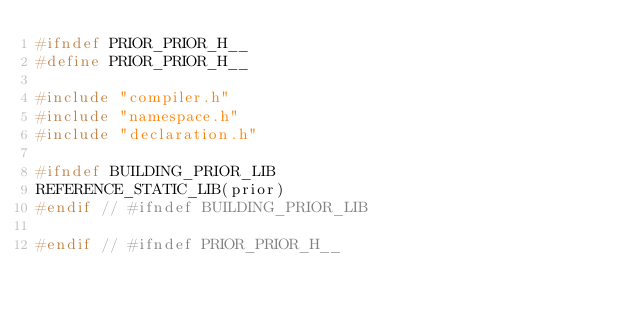Convert code to text. <code><loc_0><loc_0><loc_500><loc_500><_C_>#ifndef PRIOR_PRIOR_H__
#define PRIOR_PRIOR_H__

#include "compiler.h"
#include "namespace.h"
#include "declaration.h"

#ifndef BUILDING_PRIOR_LIB
REFERENCE_STATIC_LIB(prior)
#endif // #ifndef BUILDING_PRIOR_LIB

#endif // #ifndef PRIOR_PRIOR_H__
</code> 